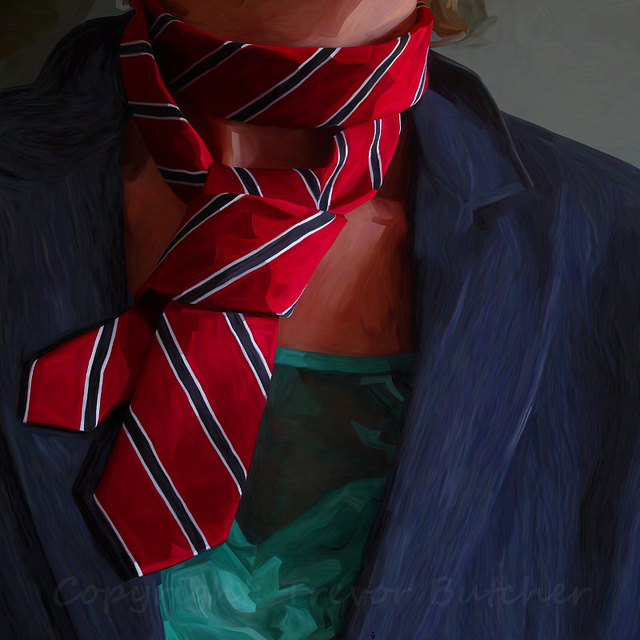<image>What type of pattern is the red fabric? I am not sure what type of pattern the red fabric has. It could be striped or solid. What type of pattern is the red fabric? The type of pattern on the red fabric is striped. 